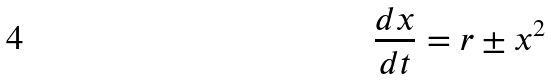<formula> <loc_0><loc_0><loc_500><loc_500>\frac { d x } { d t } = r \pm x ^ { 2 }</formula> 